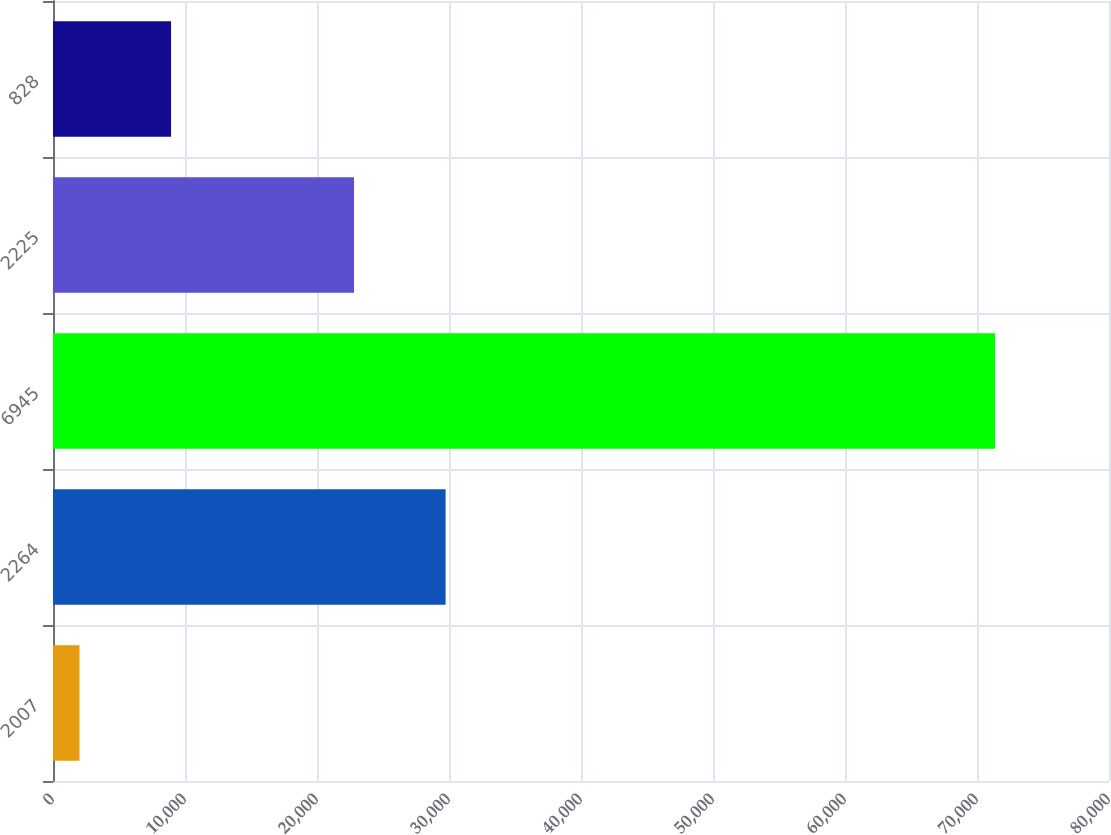Convert chart to OTSL. <chart><loc_0><loc_0><loc_500><loc_500><bar_chart><fcel>2007<fcel>2264<fcel>6945<fcel>2225<fcel>828<nl><fcel>2007<fcel>29741.5<fcel>71372<fcel>22805<fcel>8943.5<nl></chart> 